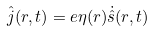Convert formula to latex. <formula><loc_0><loc_0><loc_500><loc_500>\hat { j } ( r , t ) = e \eta ( r ) \dot { \hat { s } } ( r , t )</formula> 